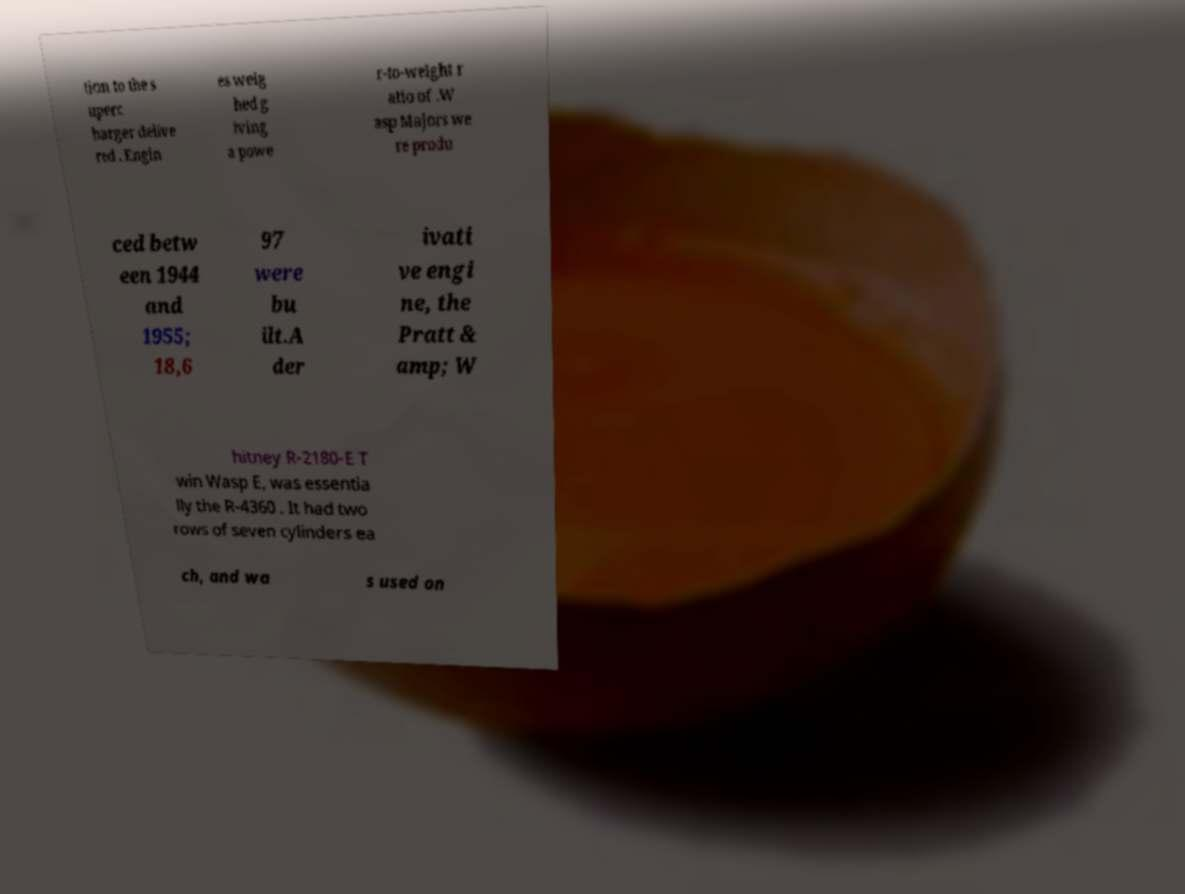Could you assist in decoding the text presented in this image and type it out clearly? tion to the s uperc harger delive red . Engin es weig hed g iving a powe r-to-weight r atio of .W asp Majors we re produ ced betw een 1944 and 1955; 18,6 97 were bu ilt.A der ivati ve engi ne, the Pratt & amp; W hitney R-2180-E T win Wasp E, was essentia lly the R-4360 . It had two rows of seven cylinders ea ch, and wa s used on 